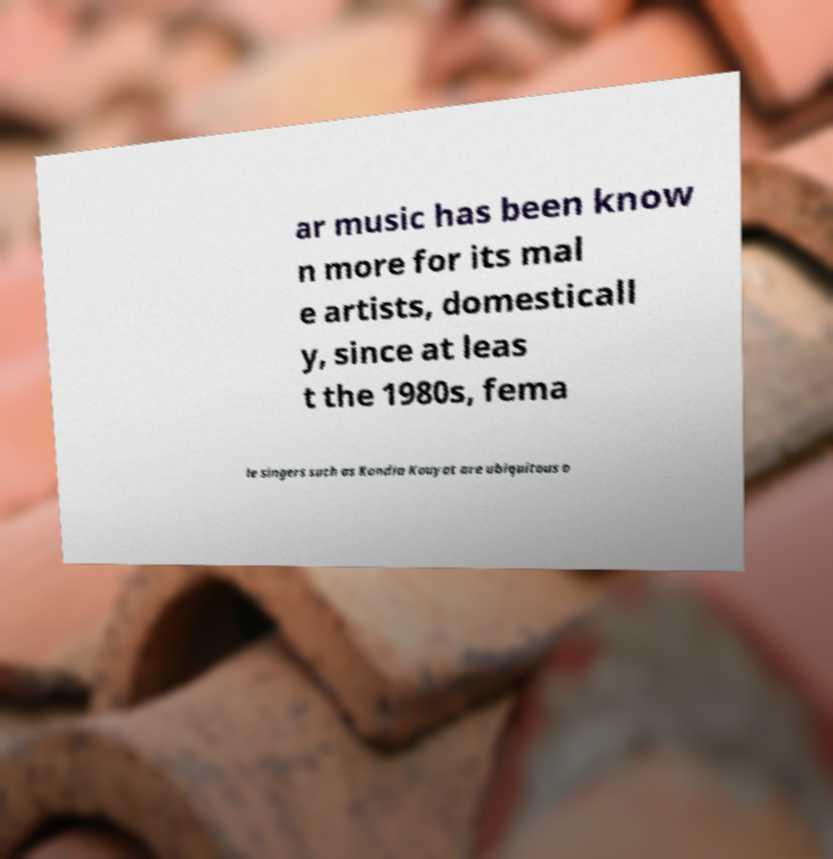What messages or text are displayed in this image? I need them in a readable, typed format. ar music has been know n more for its mal e artists, domesticall y, since at leas t the 1980s, fema le singers such as Kandia Kouyat are ubiquitous o 